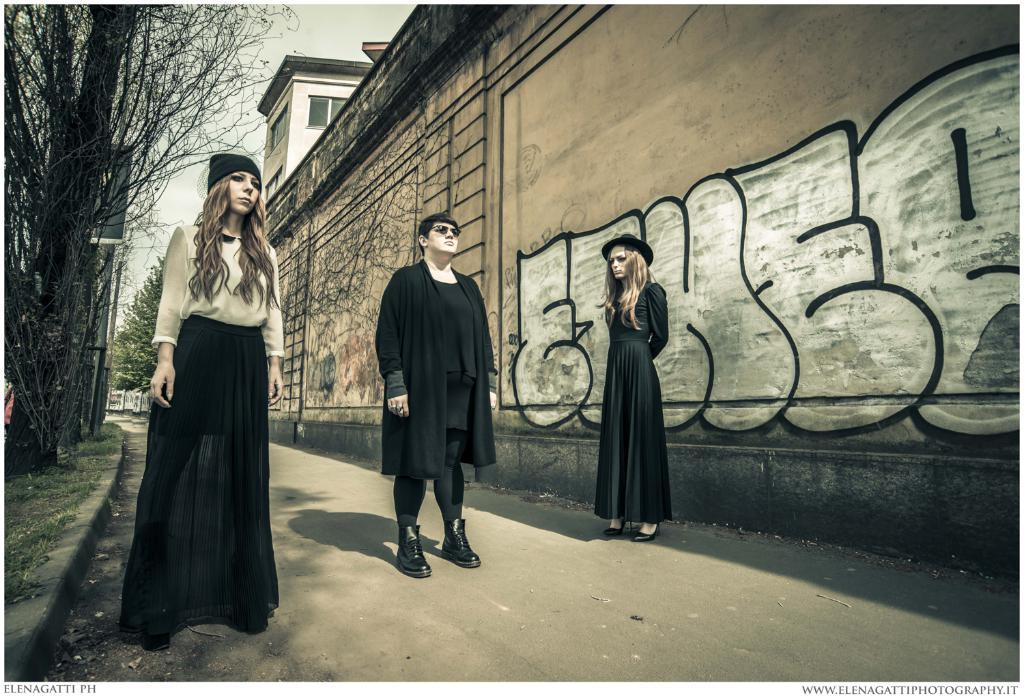How many people are present in the image? There are three people in the image: one man and two women. What are the people in the image doing? The man and women are standing on the road. What can be seen in the background of the image? There are trees, a building, a wall with a painting, and the sky visible in the background of the image. What is the size of the judge's gavel in the image? There is no judge or gavel present in the image. What theory is being discussed by the people in the image? There is no discussion or theory mentioned in the image. 